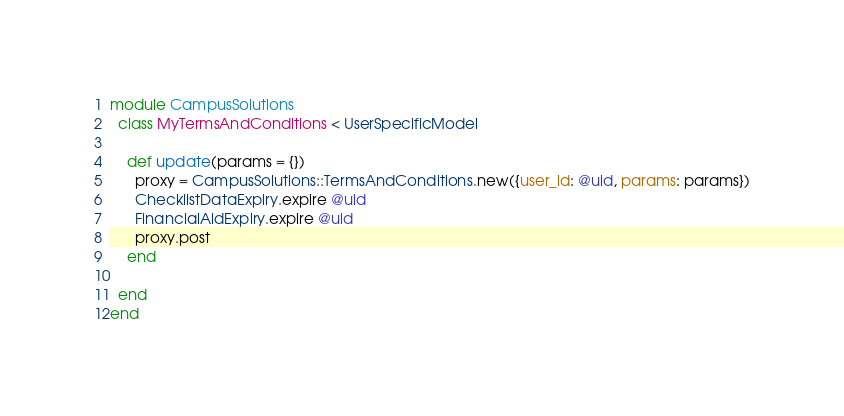Convert code to text. <code><loc_0><loc_0><loc_500><loc_500><_Ruby_>module CampusSolutions
  class MyTermsAndConditions < UserSpecificModel

    def update(params = {})
      proxy = CampusSolutions::TermsAndConditions.new({user_id: @uid, params: params})
      ChecklistDataExpiry.expire @uid
      FinancialAidExpiry.expire @uid
      proxy.post
    end

  end
end
</code> 